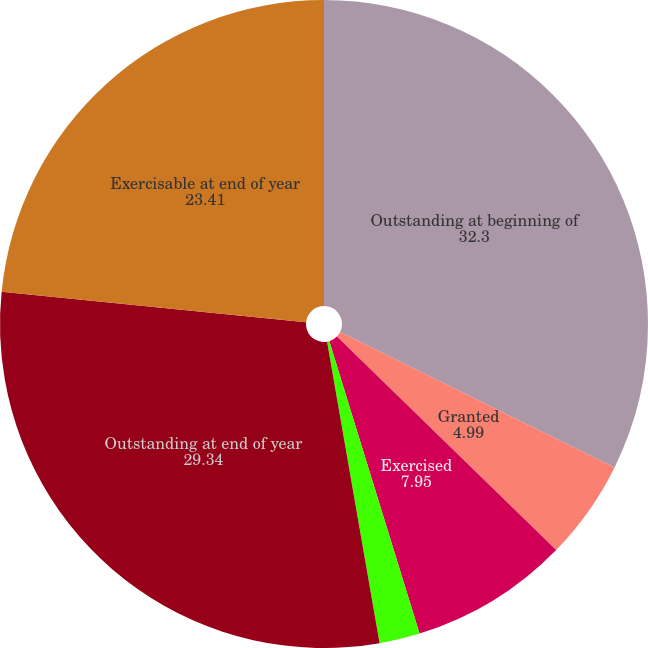<chart> <loc_0><loc_0><loc_500><loc_500><pie_chart><fcel>Outstanding at beginning of<fcel>Granted<fcel>Exercised<fcel>Expired or canceled<fcel>Outstanding at end of year<fcel>Exercisable at end of year<nl><fcel>32.3%<fcel>4.99%<fcel>7.95%<fcel>2.02%<fcel>29.34%<fcel>23.41%<nl></chart> 